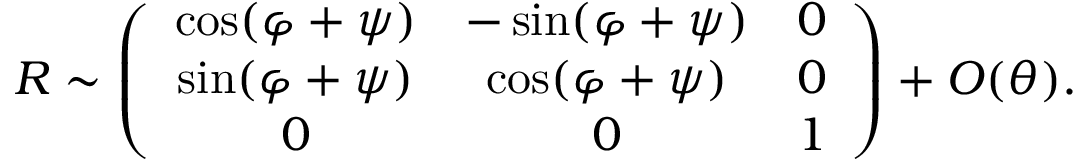<formula> <loc_0><loc_0><loc_500><loc_500>\begin{array} { r } { R \sim \left ( \begin{array} { c c c } { \cos ( \varphi + \psi ) } & { - \sin ( \varphi + \psi ) } & { 0 } \\ { \sin ( \varphi + \psi ) } & { \cos ( \varphi + \psi ) } & { 0 } \\ { 0 } & { 0 } & { 1 } \end{array} \right ) + O ( \theta ) . } \end{array}</formula> 